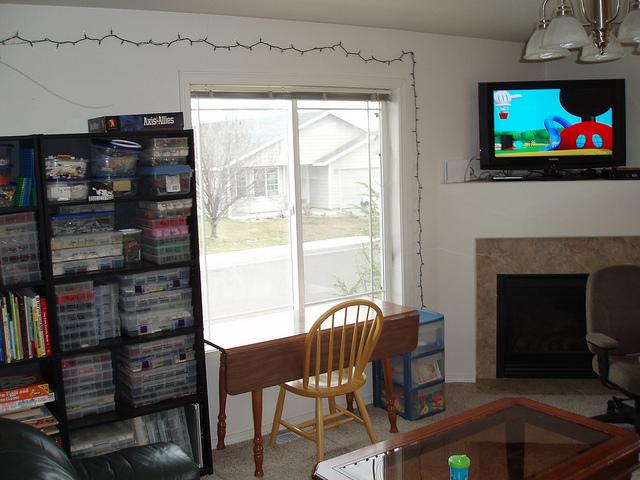Who is the red character at top?
Short answer required. Mickey mouse. Is there more than one speaker in this picture?
Quick response, please. No. How many screens are on?
Concise answer only. 1. Can more than three people eat together here?
Give a very brief answer. No. Are the lamps above the windows lit or off?
Answer briefly. Off. Does the window face the street?
Concise answer only. Yes. Is the tv on?
Keep it brief. Yes. What is the wall's color?
Answer briefly. White. What color are the walls?
Give a very brief answer. White. 